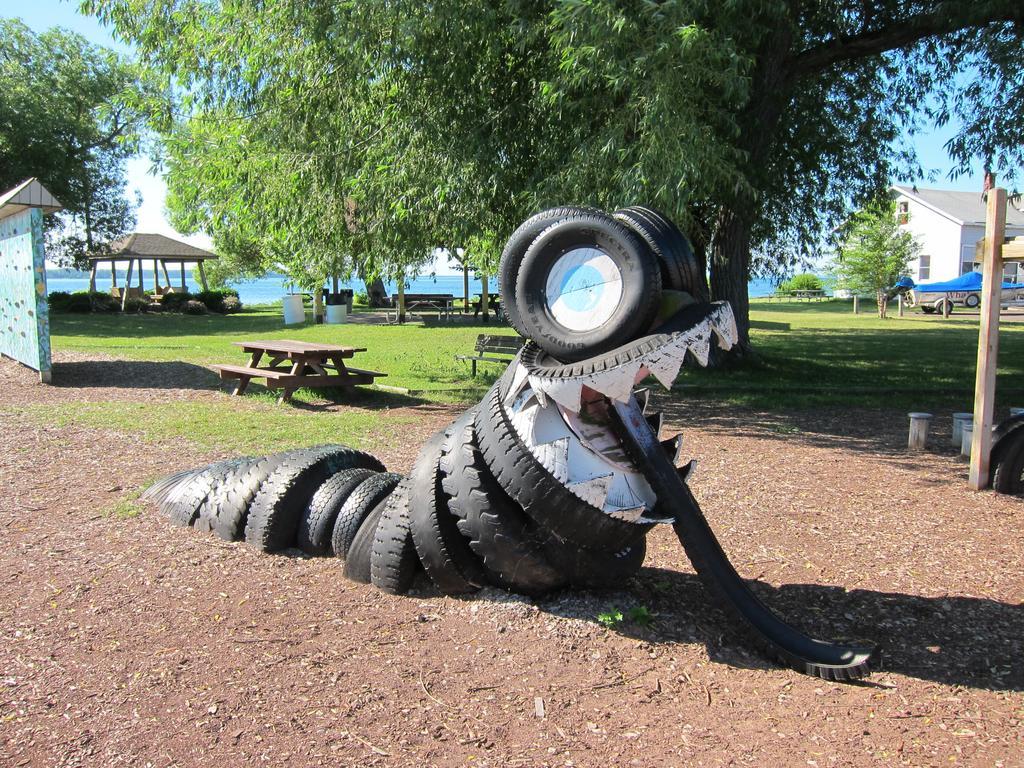In one or two sentences, can you explain what this image depicts? This is an outside view. In the middle of the image there are few tires placed on the ground. In the background there are few trees and benches on the ground and also I can see the grass. On the right side there is a building and a vehicle. On the left side there is a shed and a wall. In the background it seems to be the water and also I can see the sky in blue color. 